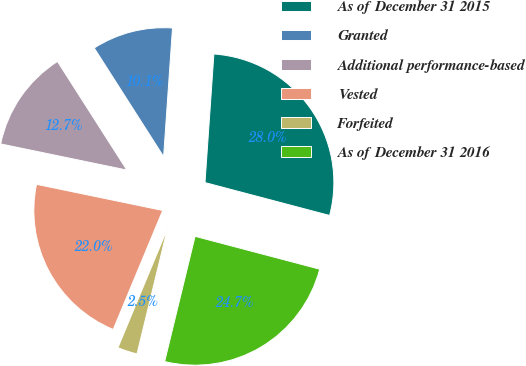Convert chart to OTSL. <chart><loc_0><loc_0><loc_500><loc_500><pie_chart><fcel>As of December 31 2015<fcel>Granted<fcel>Additional performance-based<fcel>Vested<fcel>Forfeited<fcel>As of December 31 2016<nl><fcel>28.01%<fcel>10.15%<fcel>12.7%<fcel>21.98%<fcel>2.48%<fcel>24.69%<nl></chart> 